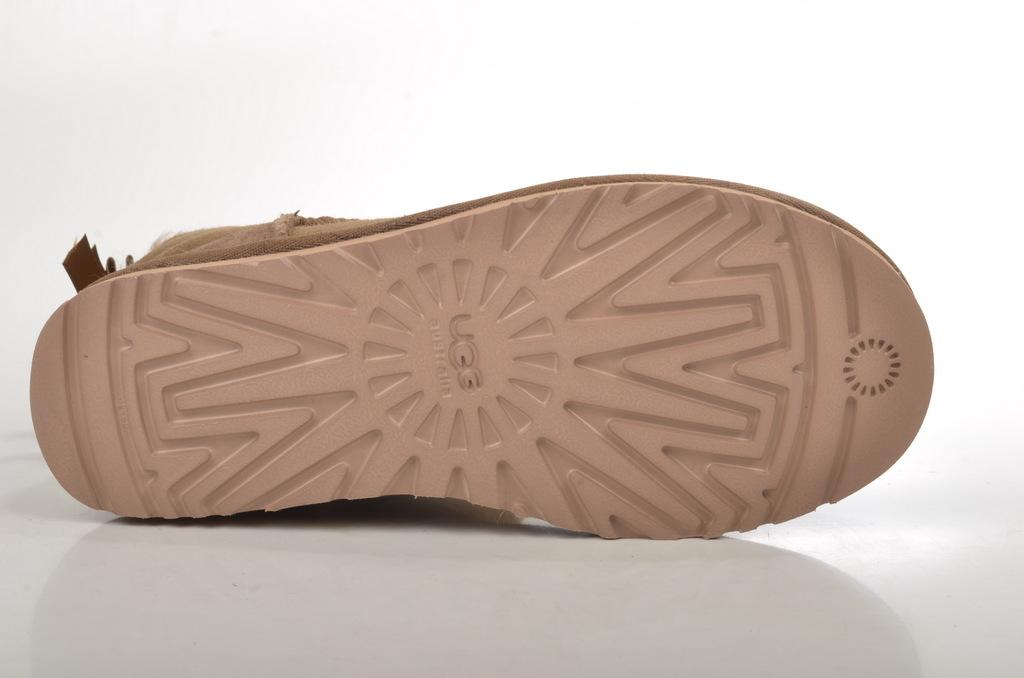What object is the main subject of the image? There is a shoe in the image. What is the color of the surface the shoe is placed on? The shoe is on a white surface. What can be seen in the background of the image? There is a plain wall in the background of the image. What type of sign can be seen in the image? There is no sign present in the image; it features a shoe on a white surface with a plain wall in the background. Can you see a baseball bat in the image? There is no baseball bat present in the image. 